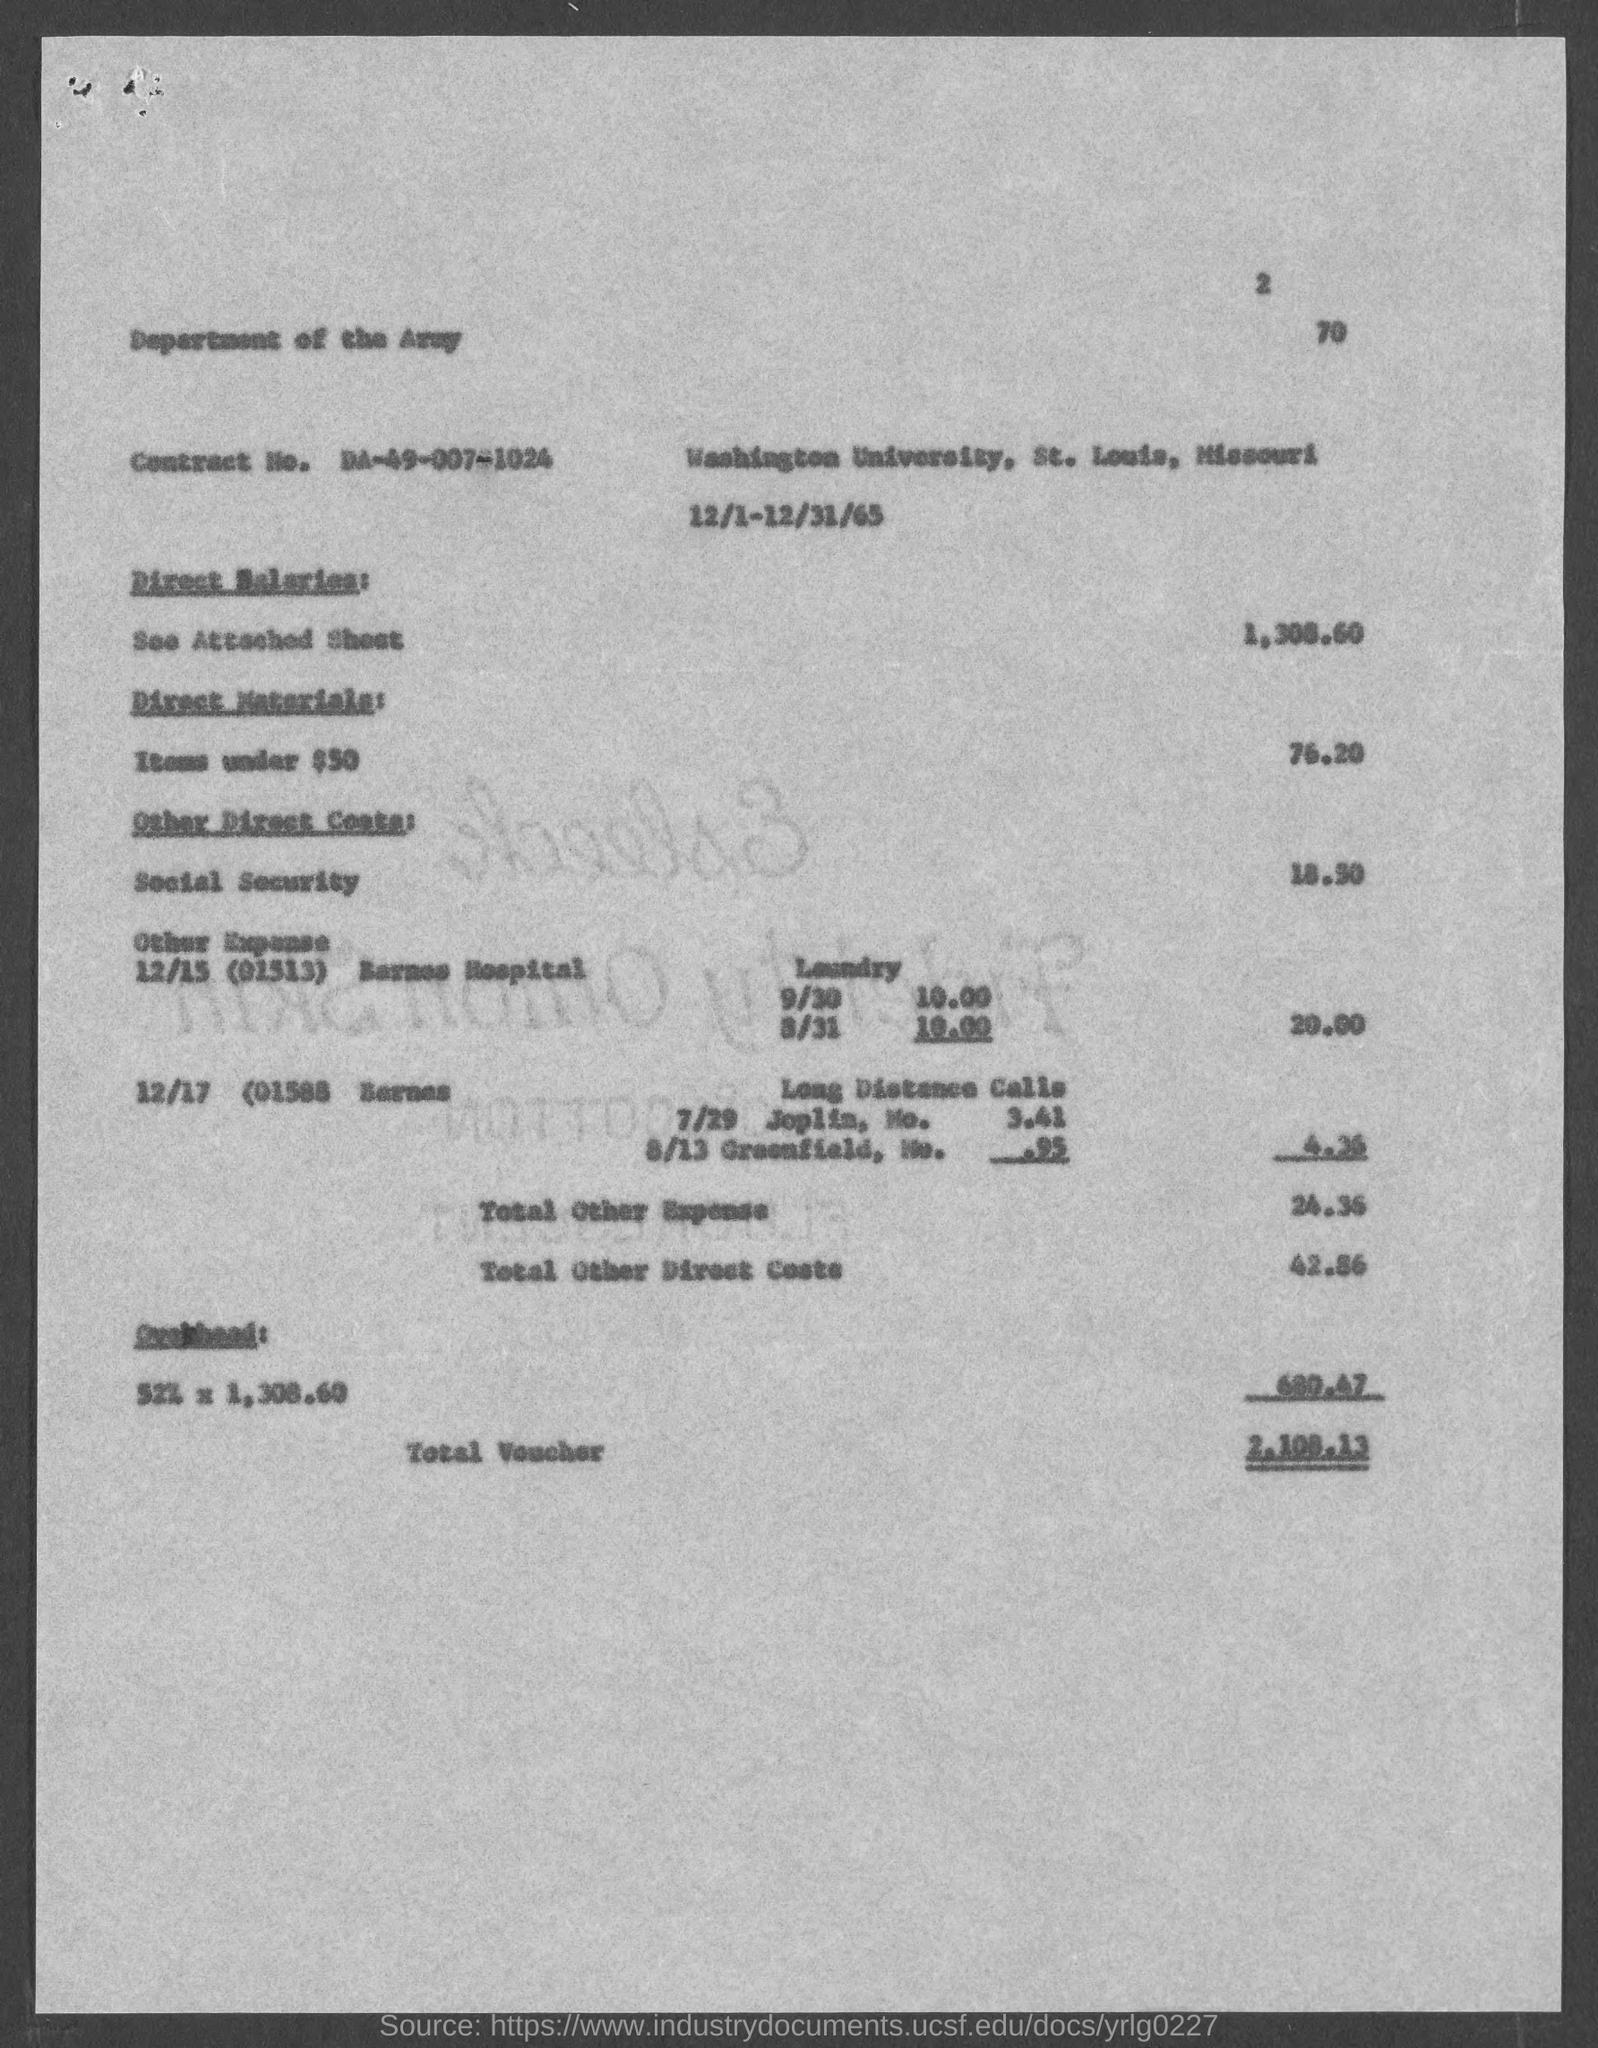Give some essential details in this illustration. The total voucher amount is $2,108.13. At the top of the page, the current page number is 2. The contract number is DA-49-007-1024. 